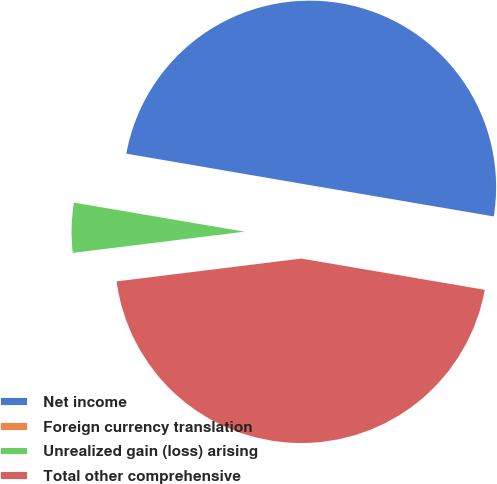Convert chart to OTSL. <chart><loc_0><loc_0><loc_500><loc_500><pie_chart><fcel>Net income<fcel>Foreign currency translation<fcel>Unrealized gain (loss) arising<fcel>Total other comprehensive<nl><fcel>49.98%<fcel>0.02%<fcel>4.64%<fcel>45.36%<nl></chart> 